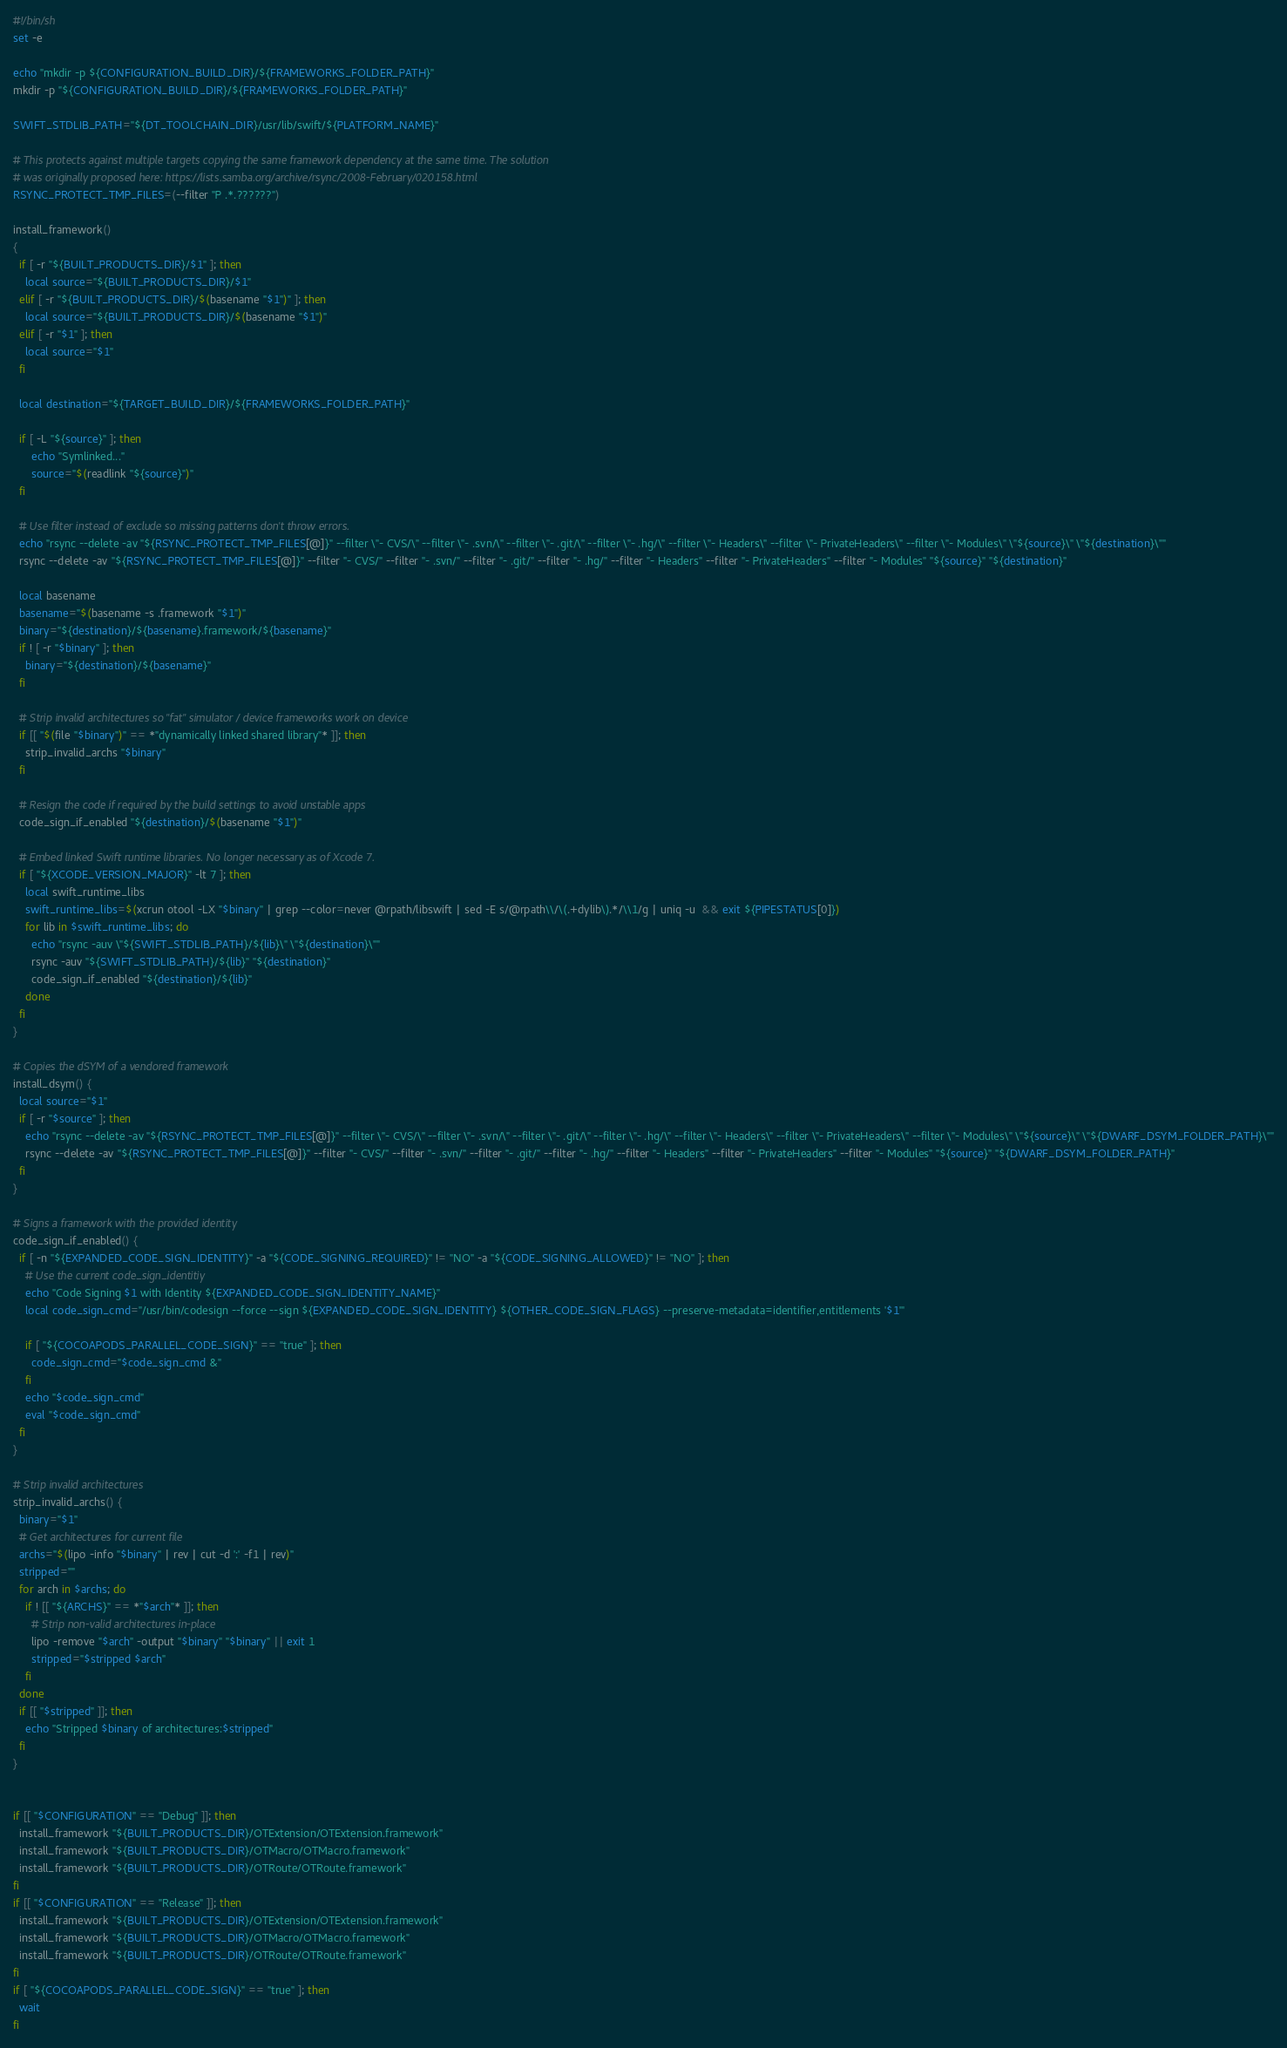Convert code to text. <code><loc_0><loc_0><loc_500><loc_500><_Bash_>#!/bin/sh
set -e

echo "mkdir -p ${CONFIGURATION_BUILD_DIR}/${FRAMEWORKS_FOLDER_PATH}"
mkdir -p "${CONFIGURATION_BUILD_DIR}/${FRAMEWORKS_FOLDER_PATH}"

SWIFT_STDLIB_PATH="${DT_TOOLCHAIN_DIR}/usr/lib/swift/${PLATFORM_NAME}"

# This protects against multiple targets copying the same framework dependency at the same time. The solution
# was originally proposed here: https://lists.samba.org/archive/rsync/2008-February/020158.html
RSYNC_PROTECT_TMP_FILES=(--filter "P .*.??????")

install_framework()
{
  if [ -r "${BUILT_PRODUCTS_DIR}/$1" ]; then
    local source="${BUILT_PRODUCTS_DIR}/$1"
  elif [ -r "${BUILT_PRODUCTS_DIR}/$(basename "$1")" ]; then
    local source="${BUILT_PRODUCTS_DIR}/$(basename "$1")"
  elif [ -r "$1" ]; then
    local source="$1"
  fi

  local destination="${TARGET_BUILD_DIR}/${FRAMEWORKS_FOLDER_PATH}"

  if [ -L "${source}" ]; then
      echo "Symlinked..."
      source="$(readlink "${source}")"
  fi

  # Use filter instead of exclude so missing patterns don't throw errors.
  echo "rsync --delete -av "${RSYNC_PROTECT_TMP_FILES[@]}" --filter \"- CVS/\" --filter \"- .svn/\" --filter \"- .git/\" --filter \"- .hg/\" --filter \"- Headers\" --filter \"- PrivateHeaders\" --filter \"- Modules\" \"${source}\" \"${destination}\""
  rsync --delete -av "${RSYNC_PROTECT_TMP_FILES[@]}" --filter "- CVS/" --filter "- .svn/" --filter "- .git/" --filter "- .hg/" --filter "- Headers" --filter "- PrivateHeaders" --filter "- Modules" "${source}" "${destination}"

  local basename
  basename="$(basename -s .framework "$1")"
  binary="${destination}/${basename}.framework/${basename}"
  if ! [ -r "$binary" ]; then
    binary="${destination}/${basename}"
  fi

  # Strip invalid architectures so "fat" simulator / device frameworks work on device
  if [[ "$(file "$binary")" == *"dynamically linked shared library"* ]]; then
    strip_invalid_archs "$binary"
  fi

  # Resign the code if required by the build settings to avoid unstable apps
  code_sign_if_enabled "${destination}/$(basename "$1")"

  # Embed linked Swift runtime libraries. No longer necessary as of Xcode 7.
  if [ "${XCODE_VERSION_MAJOR}" -lt 7 ]; then
    local swift_runtime_libs
    swift_runtime_libs=$(xcrun otool -LX "$binary" | grep --color=never @rpath/libswift | sed -E s/@rpath\\/\(.+dylib\).*/\\1/g | uniq -u  && exit ${PIPESTATUS[0]})
    for lib in $swift_runtime_libs; do
      echo "rsync -auv \"${SWIFT_STDLIB_PATH}/${lib}\" \"${destination}\""
      rsync -auv "${SWIFT_STDLIB_PATH}/${lib}" "${destination}"
      code_sign_if_enabled "${destination}/${lib}"
    done
  fi
}

# Copies the dSYM of a vendored framework
install_dsym() {
  local source="$1"
  if [ -r "$source" ]; then
    echo "rsync --delete -av "${RSYNC_PROTECT_TMP_FILES[@]}" --filter \"- CVS/\" --filter \"- .svn/\" --filter \"- .git/\" --filter \"- .hg/\" --filter \"- Headers\" --filter \"- PrivateHeaders\" --filter \"- Modules\" \"${source}\" \"${DWARF_DSYM_FOLDER_PATH}\""
    rsync --delete -av "${RSYNC_PROTECT_TMP_FILES[@]}" --filter "- CVS/" --filter "- .svn/" --filter "- .git/" --filter "- .hg/" --filter "- Headers" --filter "- PrivateHeaders" --filter "- Modules" "${source}" "${DWARF_DSYM_FOLDER_PATH}"
  fi
}

# Signs a framework with the provided identity
code_sign_if_enabled() {
  if [ -n "${EXPANDED_CODE_SIGN_IDENTITY}" -a "${CODE_SIGNING_REQUIRED}" != "NO" -a "${CODE_SIGNING_ALLOWED}" != "NO" ]; then
    # Use the current code_sign_identitiy
    echo "Code Signing $1 with Identity ${EXPANDED_CODE_SIGN_IDENTITY_NAME}"
    local code_sign_cmd="/usr/bin/codesign --force --sign ${EXPANDED_CODE_SIGN_IDENTITY} ${OTHER_CODE_SIGN_FLAGS} --preserve-metadata=identifier,entitlements '$1'"

    if [ "${COCOAPODS_PARALLEL_CODE_SIGN}" == "true" ]; then
      code_sign_cmd="$code_sign_cmd &"
    fi
    echo "$code_sign_cmd"
    eval "$code_sign_cmd"
  fi
}

# Strip invalid architectures
strip_invalid_archs() {
  binary="$1"
  # Get architectures for current file
  archs="$(lipo -info "$binary" | rev | cut -d ':' -f1 | rev)"
  stripped=""
  for arch in $archs; do
    if ! [[ "${ARCHS}" == *"$arch"* ]]; then
      # Strip non-valid architectures in-place
      lipo -remove "$arch" -output "$binary" "$binary" || exit 1
      stripped="$stripped $arch"
    fi
  done
  if [[ "$stripped" ]]; then
    echo "Stripped $binary of architectures:$stripped"
  fi
}


if [[ "$CONFIGURATION" == "Debug" ]]; then
  install_framework "${BUILT_PRODUCTS_DIR}/OTExtension/OTExtension.framework"
  install_framework "${BUILT_PRODUCTS_DIR}/OTMacro/OTMacro.framework"
  install_framework "${BUILT_PRODUCTS_DIR}/OTRoute/OTRoute.framework"
fi
if [[ "$CONFIGURATION" == "Release" ]]; then
  install_framework "${BUILT_PRODUCTS_DIR}/OTExtension/OTExtension.framework"
  install_framework "${BUILT_PRODUCTS_DIR}/OTMacro/OTMacro.framework"
  install_framework "${BUILT_PRODUCTS_DIR}/OTRoute/OTRoute.framework"
fi
if [ "${COCOAPODS_PARALLEL_CODE_SIGN}" == "true" ]; then
  wait
fi
</code> 